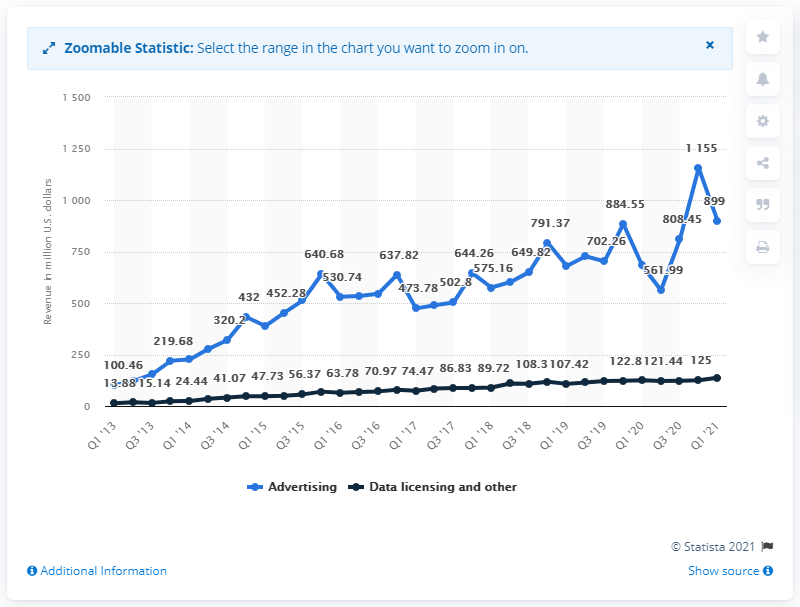Outline some significant characteristics in this image. The vast majority of Twitter's revenues are generated from advertising. In the first quarter of 2021, Twitter's advertising revenue was 899 million U.S. dollars. 